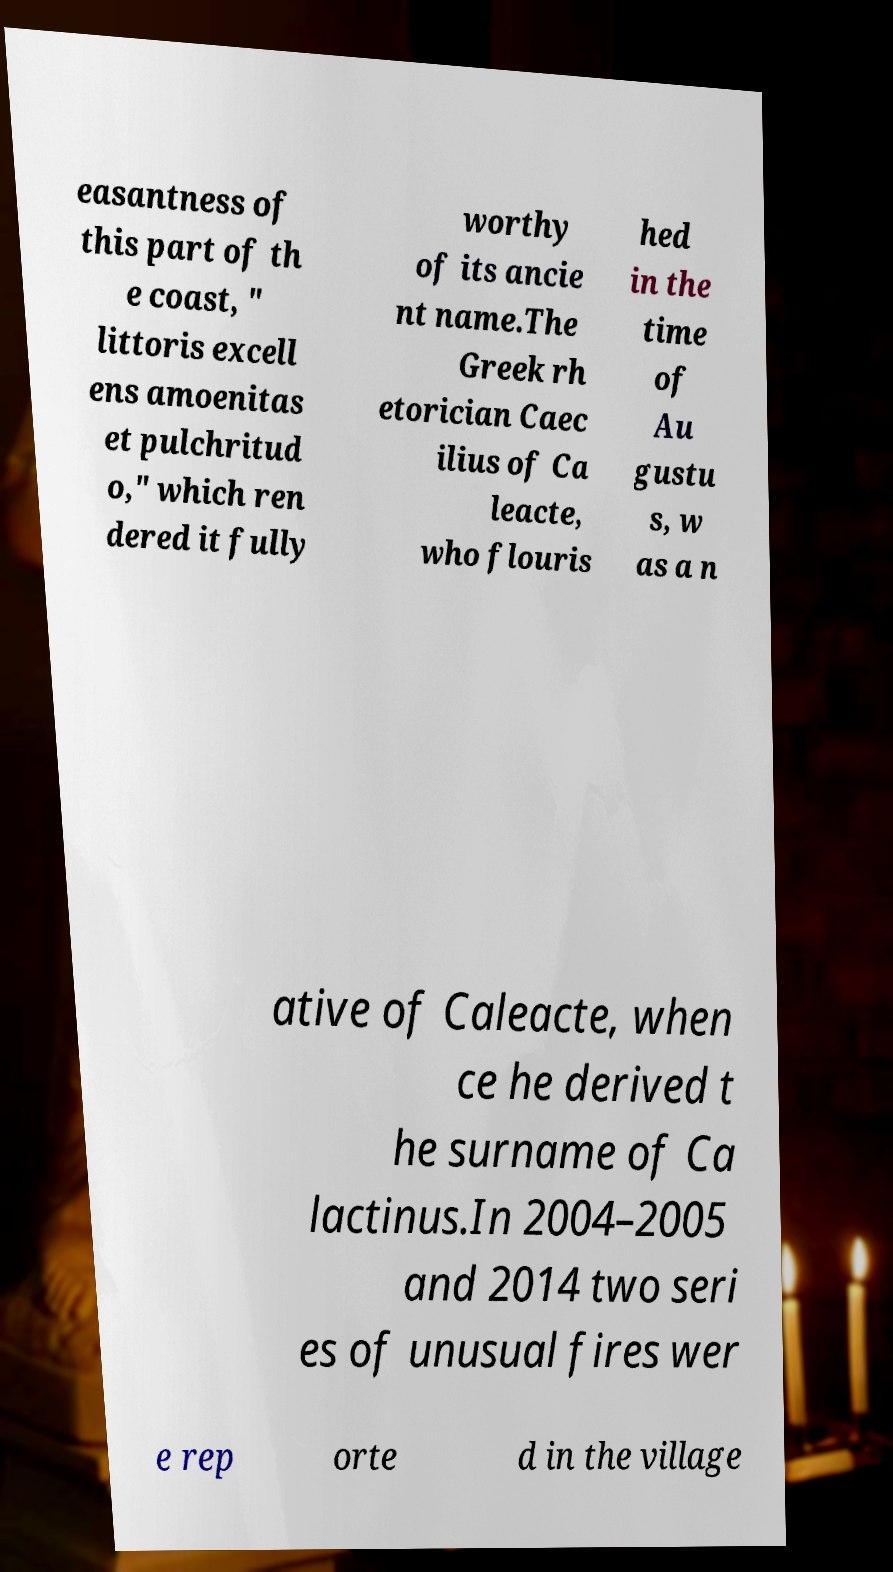I need the written content from this picture converted into text. Can you do that? easantness of this part of th e coast, " littoris excell ens amoenitas et pulchritud o," which ren dered it fully worthy of its ancie nt name.The Greek rh etorician Caec ilius of Ca leacte, who flouris hed in the time of Au gustu s, w as a n ative of Caleacte, when ce he derived t he surname of Ca lactinus.In 2004–2005 and 2014 two seri es of unusual fires wer e rep orte d in the village 